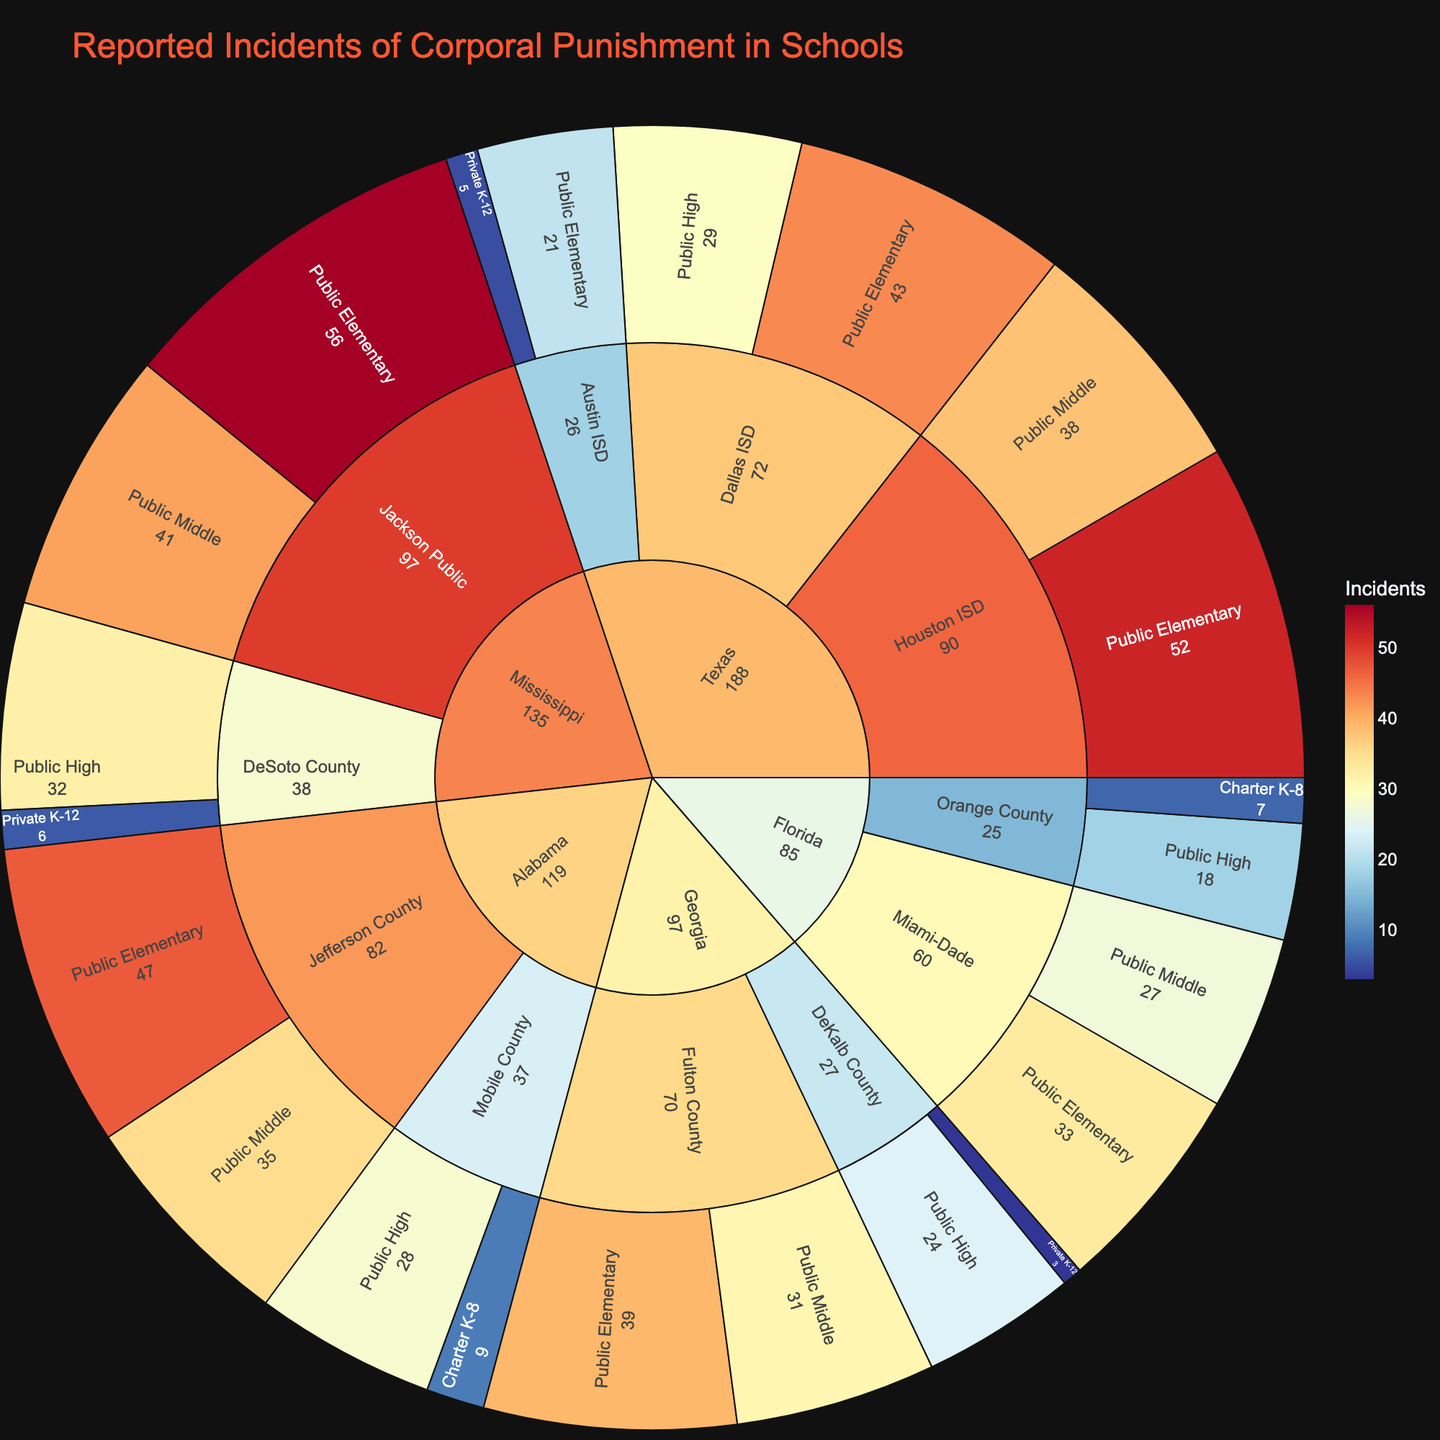What's the title of the sunburst plot? The title of a chart is usually placed at the top, to provide context and summarize the visual. Here, it is clearly displayed as 'Reported Incidents of Corporal Punishment in Schools'.
Answer: 'Reported Incidents of Corporal Punishment in Schools' Which state has reported the highest number of corporal punishment incidents? To find this, look at the first ring of the sunburst, each segment represents a state. The size of the segment and the color intensity help indicate the total number of incidents.
Answer: Mississippi What's the total number of corporal punishment incidents reported in Georgia? To find the total, sum the incidents across districts in Georgia: 39 (Fulton County Public Elementary) + 31 (Fulton County Public Middle) + 24 (DeKalb County Public High) + 3 (DeKalb County Private K-12). 39 + 31 + 24 + 3 = 97
Answer: 97 Which type of school in Texas reports the highest number of incidents? Navigate through the Texas segment and check each type of school in its districts. The school type with the highest combined incidents across districts is 'Public Elementary' (52 in Houston, 43 in Dallas, 21 in Austin). Total for Public Elementary in Texas: 52 + 43 + 21 = 116
Answer: Public Elementary Compare the incidents in public elementary schools in Texas and Alabama. Which one is higher? Compare the sum of incidents for Public Elementary schools in Texas (52 + 43 + 21 = 116) with Alabama (47). Clearly, Texas has more incidents.
Answer: Texas Which district in Florida reports the fewest incidents? Within the Florida segment, compare the incidents in each district. Orange County's 'Charter K-8' reports the fewest incidents with 7.
Answer: Orange County (Charter K-8) What is the average number of incidents reported in all districts in Mississippi? Summing incidents in Mississippi districts (Jackson Public has 56 + 41; DeSoto County has 32 + 6; Total = 135) and dividing by the number of districts (2): Average = 135/2 = 67.5
Answer: 67.5 How do the incidents in Private K-12 schools compare between Mississippi and Texas? Compare the two specific incidents: Mississippi's DeSoto County has 6 incidents, while Texas's Austin ISD has 5 incidents. Mississippi has one more incident than Texas.
Answer: Mississippi has more In which state do Public Middle schools report exactly 35 incidents? Locate the segments for each state and check the Public Middle category until you find the exact number. Alabama's Jefferson County reports exactly 35 incidents in Public Middle schools.
Answer: Alabama 